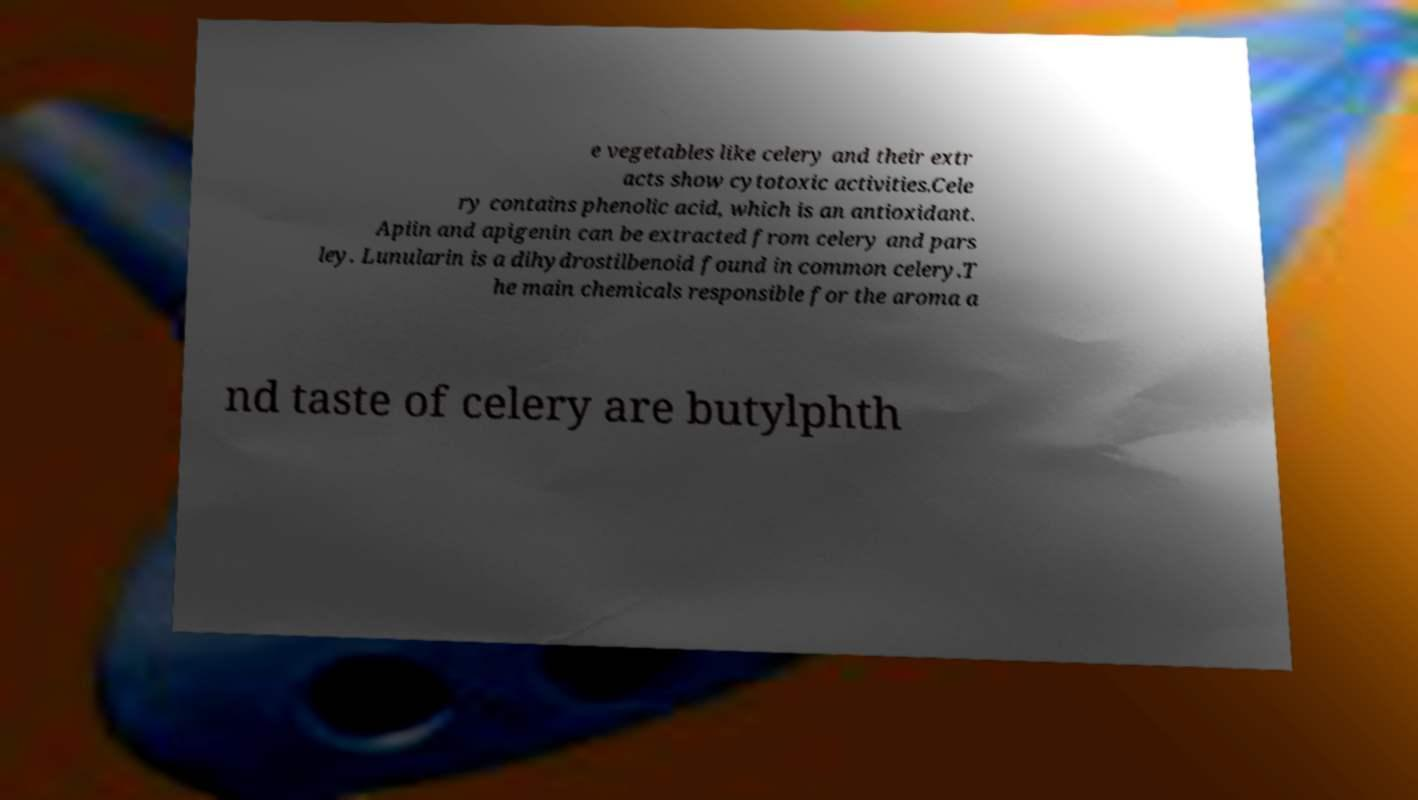Can you accurately transcribe the text from the provided image for me? e vegetables like celery and their extr acts show cytotoxic activities.Cele ry contains phenolic acid, which is an antioxidant. Apiin and apigenin can be extracted from celery and pars ley. Lunularin is a dihydrostilbenoid found in common celery.T he main chemicals responsible for the aroma a nd taste of celery are butylphth 